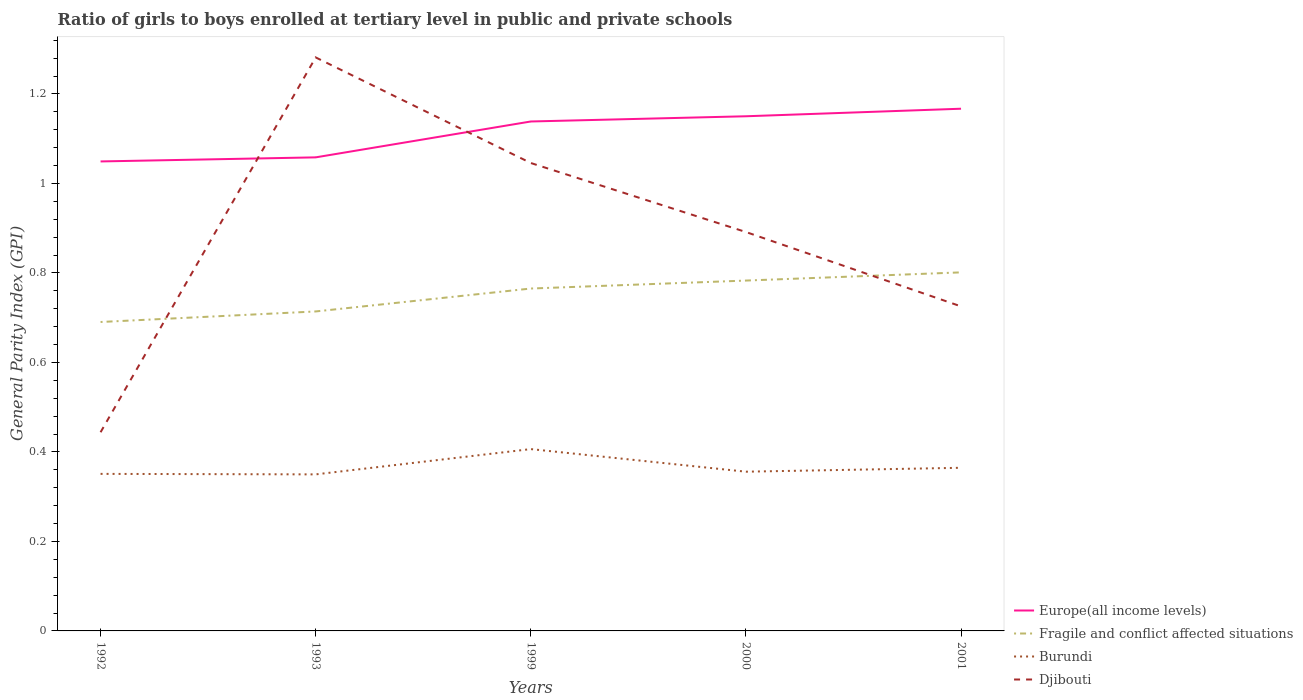How many different coloured lines are there?
Offer a very short reply. 4. Across all years, what is the maximum general parity index in Europe(all income levels)?
Provide a succinct answer. 1.05. In which year was the general parity index in Burundi maximum?
Offer a terse response. 1993. What is the total general parity index in Burundi in the graph?
Your response must be concise. 0.05. What is the difference between the highest and the second highest general parity index in Fragile and conflict affected situations?
Give a very brief answer. 0.11. Is the general parity index in Djibouti strictly greater than the general parity index in Fragile and conflict affected situations over the years?
Give a very brief answer. No. How many years are there in the graph?
Provide a short and direct response. 5. Does the graph contain any zero values?
Your response must be concise. No. Does the graph contain grids?
Offer a terse response. No. How many legend labels are there?
Give a very brief answer. 4. How are the legend labels stacked?
Give a very brief answer. Vertical. What is the title of the graph?
Ensure brevity in your answer.  Ratio of girls to boys enrolled at tertiary level in public and private schools. Does "Chad" appear as one of the legend labels in the graph?
Offer a very short reply. No. What is the label or title of the X-axis?
Ensure brevity in your answer.  Years. What is the label or title of the Y-axis?
Make the answer very short. General Parity Index (GPI). What is the General Parity Index (GPI) of Europe(all income levels) in 1992?
Offer a terse response. 1.05. What is the General Parity Index (GPI) in Fragile and conflict affected situations in 1992?
Keep it short and to the point. 0.69. What is the General Parity Index (GPI) in Burundi in 1992?
Offer a terse response. 0.35. What is the General Parity Index (GPI) in Djibouti in 1992?
Provide a short and direct response. 0.44. What is the General Parity Index (GPI) of Europe(all income levels) in 1993?
Keep it short and to the point. 1.06. What is the General Parity Index (GPI) in Fragile and conflict affected situations in 1993?
Your answer should be compact. 0.71. What is the General Parity Index (GPI) of Burundi in 1993?
Make the answer very short. 0.35. What is the General Parity Index (GPI) of Djibouti in 1993?
Offer a terse response. 1.28. What is the General Parity Index (GPI) in Europe(all income levels) in 1999?
Make the answer very short. 1.14. What is the General Parity Index (GPI) of Fragile and conflict affected situations in 1999?
Provide a succinct answer. 0.77. What is the General Parity Index (GPI) in Burundi in 1999?
Ensure brevity in your answer.  0.41. What is the General Parity Index (GPI) of Djibouti in 1999?
Offer a terse response. 1.05. What is the General Parity Index (GPI) of Europe(all income levels) in 2000?
Ensure brevity in your answer.  1.15. What is the General Parity Index (GPI) in Fragile and conflict affected situations in 2000?
Give a very brief answer. 0.78. What is the General Parity Index (GPI) in Burundi in 2000?
Provide a succinct answer. 0.36. What is the General Parity Index (GPI) in Djibouti in 2000?
Give a very brief answer. 0.89. What is the General Parity Index (GPI) in Europe(all income levels) in 2001?
Give a very brief answer. 1.17. What is the General Parity Index (GPI) of Fragile and conflict affected situations in 2001?
Your answer should be very brief. 0.8. What is the General Parity Index (GPI) of Burundi in 2001?
Your answer should be compact. 0.36. What is the General Parity Index (GPI) of Djibouti in 2001?
Provide a short and direct response. 0.73. Across all years, what is the maximum General Parity Index (GPI) in Europe(all income levels)?
Ensure brevity in your answer.  1.17. Across all years, what is the maximum General Parity Index (GPI) of Fragile and conflict affected situations?
Your answer should be very brief. 0.8. Across all years, what is the maximum General Parity Index (GPI) in Burundi?
Your answer should be compact. 0.41. Across all years, what is the maximum General Parity Index (GPI) of Djibouti?
Offer a very short reply. 1.28. Across all years, what is the minimum General Parity Index (GPI) of Europe(all income levels)?
Provide a short and direct response. 1.05. Across all years, what is the minimum General Parity Index (GPI) in Fragile and conflict affected situations?
Your response must be concise. 0.69. Across all years, what is the minimum General Parity Index (GPI) of Burundi?
Your answer should be very brief. 0.35. Across all years, what is the minimum General Parity Index (GPI) of Djibouti?
Make the answer very short. 0.44. What is the total General Parity Index (GPI) in Europe(all income levels) in the graph?
Your answer should be very brief. 5.56. What is the total General Parity Index (GPI) in Fragile and conflict affected situations in the graph?
Provide a succinct answer. 3.75. What is the total General Parity Index (GPI) of Burundi in the graph?
Ensure brevity in your answer.  1.83. What is the total General Parity Index (GPI) of Djibouti in the graph?
Your answer should be very brief. 4.39. What is the difference between the General Parity Index (GPI) of Europe(all income levels) in 1992 and that in 1993?
Make the answer very short. -0.01. What is the difference between the General Parity Index (GPI) of Fragile and conflict affected situations in 1992 and that in 1993?
Give a very brief answer. -0.02. What is the difference between the General Parity Index (GPI) in Burundi in 1992 and that in 1993?
Your answer should be compact. 0. What is the difference between the General Parity Index (GPI) in Djibouti in 1992 and that in 1993?
Ensure brevity in your answer.  -0.84. What is the difference between the General Parity Index (GPI) in Europe(all income levels) in 1992 and that in 1999?
Make the answer very short. -0.09. What is the difference between the General Parity Index (GPI) in Fragile and conflict affected situations in 1992 and that in 1999?
Your answer should be compact. -0.07. What is the difference between the General Parity Index (GPI) in Burundi in 1992 and that in 1999?
Give a very brief answer. -0.06. What is the difference between the General Parity Index (GPI) in Djibouti in 1992 and that in 1999?
Provide a succinct answer. -0.6. What is the difference between the General Parity Index (GPI) of Europe(all income levels) in 1992 and that in 2000?
Make the answer very short. -0.1. What is the difference between the General Parity Index (GPI) in Fragile and conflict affected situations in 1992 and that in 2000?
Offer a very short reply. -0.09. What is the difference between the General Parity Index (GPI) of Burundi in 1992 and that in 2000?
Your response must be concise. -0. What is the difference between the General Parity Index (GPI) of Djibouti in 1992 and that in 2000?
Give a very brief answer. -0.45. What is the difference between the General Parity Index (GPI) of Europe(all income levels) in 1992 and that in 2001?
Keep it short and to the point. -0.12. What is the difference between the General Parity Index (GPI) in Fragile and conflict affected situations in 1992 and that in 2001?
Your answer should be compact. -0.11. What is the difference between the General Parity Index (GPI) in Burundi in 1992 and that in 2001?
Offer a very short reply. -0.01. What is the difference between the General Parity Index (GPI) in Djibouti in 1992 and that in 2001?
Your response must be concise. -0.28. What is the difference between the General Parity Index (GPI) in Europe(all income levels) in 1993 and that in 1999?
Offer a terse response. -0.08. What is the difference between the General Parity Index (GPI) of Fragile and conflict affected situations in 1993 and that in 1999?
Your answer should be very brief. -0.05. What is the difference between the General Parity Index (GPI) of Burundi in 1993 and that in 1999?
Offer a very short reply. -0.06. What is the difference between the General Parity Index (GPI) in Djibouti in 1993 and that in 1999?
Your response must be concise. 0.24. What is the difference between the General Parity Index (GPI) of Europe(all income levels) in 1993 and that in 2000?
Give a very brief answer. -0.09. What is the difference between the General Parity Index (GPI) of Fragile and conflict affected situations in 1993 and that in 2000?
Your answer should be compact. -0.07. What is the difference between the General Parity Index (GPI) of Burundi in 1993 and that in 2000?
Make the answer very short. -0.01. What is the difference between the General Parity Index (GPI) of Djibouti in 1993 and that in 2000?
Give a very brief answer. 0.39. What is the difference between the General Parity Index (GPI) of Europe(all income levels) in 1993 and that in 2001?
Your answer should be compact. -0.11. What is the difference between the General Parity Index (GPI) in Fragile and conflict affected situations in 1993 and that in 2001?
Your answer should be compact. -0.09. What is the difference between the General Parity Index (GPI) in Burundi in 1993 and that in 2001?
Offer a terse response. -0.01. What is the difference between the General Parity Index (GPI) of Djibouti in 1993 and that in 2001?
Ensure brevity in your answer.  0.56. What is the difference between the General Parity Index (GPI) in Europe(all income levels) in 1999 and that in 2000?
Provide a succinct answer. -0.01. What is the difference between the General Parity Index (GPI) in Fragile and conflict affected situations in 1999 and that in 2000?
Your response must be concise. -0.02. What is the difference between the General Parity Index (GPI) of Burundi in 1999 and that in 2000?
Provide a short and direct response. 0.05. What is the difference between the General Parity Index (GPI) of Djibouti in 1999 and that in 2000?
Provide a succinct answer. 0.15. What is the difference between the General Parity Index (GPI) of Europe(all income levels) in 1999 and that in 2001?
Make the answer very short. -0.03. What is the difference between the General Parity Index (GPI) in Fragile and conflict affected situations in 1999 and that in 2001?
Ensure brevity in your answer.  -0.04. What is the difference between the General Parity Index (GPI) in Burundi in 1999 and that in 2001?
Offer a very short reply. 0.04. What is the difference between the General Parity Index (GPI) of Djibouti in 1999 and that in 2001?
Ensure brevity in your answer.  0.32. What is the difference between the General Parity Index (GPI) of Europe(all income levels) in 2000 and that in 2001?
Your answer should be compact. -0.02. What is the difference between the General Parity Index (GPI) of Fragile and conflict affected situations in 2000 and that in 2001?
Give a very brief answer. -0.02. What is the difference between the General Parity Index (GPI) of Burundi in 2000 and that in 2001?
Offer a terse response. -0.01. What is the difference between the General Parity Index (GPI) in Djibouti in 2000 and that in 2001?
Your answer should be compact. 0.17. What is the difference between the General Parity Index (GPI) in Europe(all income levels) in 1992 and the General Parity Index (GPI) in Fragile and conflict affected situations in 1993?
Give a very brief answer. 0.34. What is the difference between the General Parity Index (GPI) in Europe(all income levels) in 1992 and the General Parity Index (GPI) in Burundi in 1993?
Your answer should be compact. 0.7. What is the difference between the General Parity Index (GPI) in Europe(all income levels) in 1992 and the General Parity Index (GPI) in Djibouti in 1993?
Offer a terse response. -0.23. What is the difference between the General Parity Index (GPI) of Fragile and conflict affected situations in 1992 and the General Parity Index (GPI) of Burundi in 1993?
Keep it short and to the point. 0.34. What is the difference between the General Parity Index (GPI) in Fragile and conflict affected situations in 1992 and the General Parity Index (GPI) in Djibouti in 1993?
Make the answer very short. -0.59. What is the difference between the General Parity Index (GPI) of Burundi in 1992 and the General Parity Index (GPI) of Djibouti in 1993?
Your response must be concise. -0.93. What is the difference between the General Parity Index (GPI) of Europe(all income levels) in 1992 and the General Parity Index (GPI) of Fragile and conflict affected situations in 1999?
Your answer should be compact. 0.28. What is the difference between the General Parity Index (GPI) of Europe(all income levels) in 1992 and the General Parity Index (GPI) of Burundi in 1999?
Give a very brief answer. 0.64. What is the difference between the General Parity Index (GPI) of Europe(all income levels) in 1992 and the General Parity Index (GPI) of Djibouti in 1999?
Keep it short and to the point. 0. What is the difference between the General Parity Index (GPI) in Fragile and conflict affected situations in 1992 and the General Parity Index (GPI) in Burundi in 1999?
Give a very brief answer. 0.28. What is the difference between the General Parity Index (GPI) in Fragile and conflict affected situations in 1992 and the General Parity Index (GPI) in Djibouti in 1999?
Offer a terse response. -0.36. What is the difference between the General Parity Index (GPI) in Burundi in 1992 and the General Parity Index (GPI) in Djibouti in 1999?
Provide a succinct answer. -0.69. What is the difference between the General Parity Index (GPI) of Europe(all income levels) in 1992 and the General Parity Index (GPI) of Fragile and conflict affected situations in 2000?
Your answer should be compact. 0.27. What is the difference between the General Parity Index (GPI) in Europe(all income levels) in 1992 and the General Parity Index (GPI) in Burundi in 2000?
Offer a very short reply. 0.69. What is the difference between the General Parity Index (GPI) of Europe(all income levels) in 1992 and the General Parity Index (GPI) of Djibouti in 2000?
Offer a very short reply. 0.16. What is the difference between the General Parity Index (GPI) in Fragile and conflict affected situations in 1992 and the General Parity Index (GPI) in Burundi in 2000?
Your response must be concise. 0.33. What is the difference between the General Parity Index (GPI) of Fragile and conflict affected situations in 1992 and the General Parity Index (GPI) of Djibouti in 2000?
Make the answer very short. -0.2. What is the difference between the General Parity Index (GPI) in Burundi in 1992 and the General Parity Index (GPI) in Djibouti in 2000?
Your response must be concise. -0.54. What is the difference between the General Parity Index (GPI) of Europe(all income levels) in 1992 and the General Parity Index (GPI) of Fragile and conflict affected situations in 2001?
Provide a short and direct response. 0.25. What is the difference between the General Parity Index (GPI) of Europe(all income levels) in 1992 and the General Parity Index (GPI) of Burundi in 2001?
Your answer should be very brief. 0.68. What is the difference between the General Parity Index (GPI) of Europe(all income levels) in 1992 and the General Parity Index (GPI) of Djibouti in 2001?
Keep it short and to the point. 0.32. What is the difference between the General Parity Index (GPI) of Fragile and conflict affected situations in 1992 and the General Parity Index (GPI) of Burundi in 2001?
Offer a very short reply. 0.33. What is the difference between the General Parity Index (GPI) in Fragile and conflict affected situations in 1992 and the General Parity Index (GPI) in Djibouti in 2001?
Your answer should be compact. -0.03. What is the difference between the General Parity Index (GPI) in Burundi in 1992 and the General Parity Index (GPI) in Djibouti in 2001?
Give a very brief answer. -0.37. What is the difference between the General Parity Index (GPI) in Europe(all income levels) in 1993 and the General Parity Index (GPI) in Fragile and conflict affected situations in 1999?
Keep it short and to the point. 0.29. What is the difference between the General Parity Index (GPI) in Europe(all income levels) in 1993 and the General Parity Index (GPI) in Burundi in 1999?
Your answer should be compact. 0.65. What is the difference between the General Parity Index (GPI) of Europe(all income levels) in 1993 and the General Parity Index (GPI) of Djibouti in 1999?
Your answer should be compact. 0.01. What is the difference between the General Parity Index (GPI) of Fragile and conflict affected situations in 1993 and the General Parity Index (GPI) of Burundi in 1999?
Make the answer very short. 0.31. What is the difference between the General Parity Index (GPI) of Fragile and conflict affected situations in 1993 and the General Parity Index (GPI) of Djibouti in 1999?
Keep it short and to the point. -0.33. What is the difference between the General Parity Index (GPI) in Burundi in 1993 and the General Parity Index (GPI) in Djibouti in 1999?
Offer a terse response. -0.7. What is the difference between the General Parity Index (GPI) in Europe(all income levels) in 1993 and the General Parity Index (GPI) in Fragile and conflict affected situations in 2000?
Ensure brevity in your answer.  0.28. What is the difference between the General Parity Index (GPI) of Europe(all income levels) in 1993 and the General Parity Index (GPI) of Burundi in 2000?
Provide a short and direct response. 0.7. What is the difference between the General Parity Index (GPI) of Europe(all income levels) in 1993 and the General Parity Index (GPI) of Djibouti in 2000?
Ensure brevity in your answer.  0.17. What is the difference between the General Parity Index (GPI) of Fragile and conflict affected situations in 1993 and the General Parity Index (GPI) of Burundi in 2000?
Make the answer very short. 0.36. What is the difference between the General Parity Index (GPI) of Fragile and conflict affected situations in 1993 and the General Parity Index (GPI) of Djibouti in 2000?
Your answer should be very brief. -0.18. What is the difference between the General Parity Index (GPI) of Burundi in 1993 and the General Parity Index (GPI) of Djibouti in 2000?
Provide a succinct answer. -0.54. What is the difference between the General Parity Index (GPI) in Europe(all income levels) in 1993 and the General Parity Index (GPI) in Fragile and conflict affected situations in 2001?
Offer a terse response. 0.26. What is the difference between the General Parity Index (GPI) in Europe(all income levels) in 1993 and the General Parity Index (GPI) in Burundi in 2001?
Offer a terse response. 0.69. What is the difference between the General Parity Index (GPI) in Europe(all income levels) in 1993 and the General Parity Index (GPI) in Djibouti in 2001?
Offer a very short reply. 0.33. What is the difference between the General Parity Index (GPI) of Fragile and conflict affected situations in 1993 and the General Parity Index (GPI) of Burundi in 2001?
Offer a terse response. 0.35. What is the difference between the General Parity Index (GPI) of Fragile and conflict affected situations in 1993 and the General Parity Index (GPI) of Djibouti in 2001?
Provide a short and direct response. -0.01. What is the difference between the General Parity Index (GPI) in Burundi in 1993 and the General Parity Index (GPI) in Djibouti in 2001?
Your response must be concise. -0.38. What is the difference between the General Parity Index (GPI) of Europe(all income levels) in 1999 and the General Parity Index (GPI) of Fragile and conflict affected situations in 2000?
Keep it short and to the point. 0.36. What is the difference between the General Parity Index (GPI) of Europe(all income levels) in 1999 and the General Parity Index (GPI) of Burundi in 2000?
Keep it short and to the point. 0.78. What is the difference between the General Parity Index (GPI) in Europe(all income levels) in 1999 and the General Parity Index (GPI) in Djibouti in 2000?
Provide a short and direct response. 0.25. What is the difference between the General Parity Index (GPI) in Fragile and conflict affected situations in 1999 and the General Parity Index (GPI) in Burundi in 2000?
Provide a succinct answer. 0.41. What is the difference between the General Parity Index (GPI) in Fragile and conflict affected situations in 1999 and the General Parity Index (GPI) in Djibouti in 2000?
Give a very brief answer. -0.13. What is the difference between the General Parity Index (GPI) of Burundi in 1999 and the General Parity Index (GPI) of Djibouti in 2000?
Provide a succinct answer. -0.49. What is the difference between the General Parity Index (GPI) in Europe(all income levels) in 1999 and the General Parity Index (GPI) in Fragile and conflict affected situations in 2001?
Provide a short and direct response. 0.34. What is the difference between the General Parity Index (GPI) in Europe(all income levels) in 1999 and the General Parity Index (GPI) in Burundi in 2001?
Ensure brevity in your answer.  0.77. What is the difference between the General Parity Index (GPI) of Europe(all income levels) in 1999 and the General Parity Index (GPI) of Djibouti in 2001?
Make the answer very short. 0.41. What is the difference between the General Parity Index (GPI) of Fragile and conflict affected situations in 1999 and the General Parity Index (GPI) of Burundi in 2001?
Offer a very short reply. 0.4. What is the difference between the General Parity Index (GPI) in Fragile and conflict affected situations in 1999 and the General Parity Index (GPI) in Djibouti in 2001?
Keep it short and to the point. 0.04. What is the difference between the General Parity Index (GPI) of Burundi in 1999 and the General Parity Index (GPI) of Djibouti in 2001?
Make the answer very short. -0.32. What is the difference between the General Parity Index (GPI) of Europe(all income levels) in 2000 and the General Parity Index (GPI) of Fragile and conflict affected situations in 2001?
Offer a terse response. 0.35. What is the difference between the General Parity Index (GPI) of Europe(all income levels) in 2000 and the General Parity Index (GPI) of Burundi in 2001?
Your answer should be compact. 0.79. What is the difference between the General Parity Index (GPI) of Europe(all income levels) in 2000 and the General Parity Index (GPI) of Djibouti in 2001?
Offer a very short reply. 0.42. What is the difference between the General Parity Index (GPI) of Fragile and conflict affected situations in 2000 and the General Parity Index (GPI) of Burundi in 2001?
Provide a short and direct response. 0.42. What is the difference between the General Parity Index (GPI) in Fragile and conflict affected situations in 2000 and the General Parity Index (GPI) in Djibouti in 2001?
Keep it short and to the point. 0.06. What is the difference between the General Parity Index (GPI) in Burundi in 2000 and the General Parity Index (GPI) in Djibouti in 2001?
Provide a succinct answer. -0.37. What is the average General Parity Index (GPI) in Europe(all income levels) per year?
Provide a short and direct response. 1.11. What is the average General Parity Index (GPI) in Fragile and conflict affected situations per year?
Your answer should be very brief. 0.75. What is the average General Parity Index (GPI) of Burundi per year?
Give a very brief answer. 0.37. What is the average General Parity Index (GPI) of Djibouti per year?
Make the answer very short. 0.88. In the year 1992, what is the difference between the General Parity Index (GPI) in Europe(all income levels) and General Parity Index (GPI) in Fragile and conflict affected situations?
Your answer should be compact. 0.36. In the year 1992, what is the difference between the General Parity Index (GPI) in Europe(all income levels) and General Parity Index (GPI) in Burundi?
Your answer should be compact. 0.7. In the year 1992, what is the difference between the General Parity Index (GPI) of Europe(all income levels) and General Parity Index (GPI) of Djibouti?
Provide a succinct answer. 0.61. In the year 1992, what is the difference between the General Parity Index (GPI) in Fragile and conflict affected situations and General Parity Index (GPI) in Burundi?
Your response must be concise. 0.34. In the year 1992, what is the difference between the General Parity Index (GPI) of Fragile and conflict affected situations and General Parity Index (GPI) of Djibouti?
Ensure brevity in your answer.  0.25. In the year 1992, what is the difference between the General Parity Index (GPI) in Burundi and General Parity Index (GPI) in Djibouti?
Offer a terse response. -0.09. In the year 1993, what is the difference between the General Parity Index (GPI) in Europe(all income levels) and General Parity Index (GPI) in Fragile and conflict affected situations?
Give a very brief answer. 0.34. In the year 1993, what is the difference between the General Parity Index (GPI) in Europe(all income levels) and General Parity Index (GPI) in Burundi?
Offer a very short reply. 0.71. In the year 1993, what is the difference between the General Parity Index (GPI) in Europe(all income levels) and General Parity Index (GPI) in Djibouti?
Provide a short and direct response. -0.22. In the year 1993, what is the difference between the General Parity Index (GPI) in Fragile and conflict affected situations and General Parity Index (GPI) in Burundi?
Provide a short and direct response. 0.36. In the year 1993, what is the difference between the General Parity Index (GPI) of Fragile and conflict affected situations and General Parity Index (GPI) of Djibouti?
Your answer should be compact. -0.57. In the year 1993, what is the difference between the General Parity Index (GPI) in Burundi and General Parity Index (GPI) in Djibouti?
Keep it short and to the point. -0.93. In the year 1999, what is the difference between the General Parity Index (GPI) of Europe(all income levels) and General Parity Index (GPI) of Fragile and conflict affected situations?
Your answer should be compact. 0.37. In the year 1999, what is the difference between the General Parity Index (GPI) in Europe(all income levels) and General Parity Index (GPI) in Burundi?
Your answer should be compact. 0.73. In the year 1999, what is the difference between the General Parity Index (GPI) of Europe(all income levels) and General Parity Index (GPI) of Djibouti?
Give a very brief answer. 0.09. In the year 1999, what is the difference between the General Parity Index (GPI) in Fragile and conflict affected situations and General Parity Index (GPI) in Burundi?
Offer a very short reply. 0.36. In the year 1999, what is the difference between the General Parity Index (GPI) in Fragile and conflict affected situations and General Parity Index (GPI) in Djibouti?
Your answer should be very brief. -0.28. In the year 1999, what is the difference between the General Parity Index (GPI) of Burundi and General Parity Index (GPI) of Djibouti?
Offer a terse response. -0.64. In the year 2000, what is the difference between the General Parity Index (GPI) of Europe(all income levels) and General Parity Index (GPI) of Fragile and conflict affected situations?
Your answer should be compact. 0.37. In the year 2000, what is the difference between the General Parity Index (GPI) in Europe(all income levels) and General Parity Index (GPI) in Burundi?
Keep it short and to the point. 0.79. In the year 2000, what is the difference between the General Parity Index (GPI) in Europe(all income levels) and General Parity Index (GPI) in Djibouti?
Offer a terse response. 0.26. In the year 2000, what is the difference between the General Parity Index (GPI) in Fragile and conflict affected situations and General Parity Index (GPI) in Burundi?
Provide a short and direct response. 0.43. In the year 2000, what is the difference between the General Parity Index (GPI) in Fragile and conflict affected situations and General Parity Index (GPI) in Djibouti?
Offer a very short reply. -0.11. In the year 2000, what is the difference between the General Parity Index (GPI) of Burundi and General Parity Index (GPI) of Djibouti?
Make the answer very short. -0.54. In the year 2001, what is the difference between the General Parity Index (GPI) in Europe(all income levels) and General Parity Index (GPI) in Fragile and conflict affected situations?
Provide a succinct answer. 0.37. In the year 2001, what is the difference between the General Parity Index (GPI) of Europe(all income levels) and General Parity Index (GPI) of Burundi?
Provide a short and direct response. 0.8. In the year 2001, what is the difference between the General Parity Index (GPI) in Europe(all income levels) and General Parity Index (GPI) in Djibouti?
Provide a succinct answer. 0.44. In the year 2001, what is the difference between the General Parity Index (GPI) in Fragile and conflict affected situations and General Parity Index (GPI) in Burundi?
Ensure brevity in your answer.  0.44. In the year 2001, what is the difference between the General Parity Index (GPI) of Fragile and conflict affected situations and General Parity Index (GPI) of Djibouti?
Make the answer very short. 0.08. In the year 2001, what is the difference between the General Parity Index (GPI) of Burundi and General Parity Index (GPI) of Djibouti?
Ensure brevity in your answer.  -0.36. What is the ratio of the General Parity Index (GPI) in Burundi in 1992 to that in 1993?
Your response must be concise. 1. What is the ratio of the General Parity Index (GPI) of Djibouti in 1992 to that in 1993?
Your response must be concise. 0.35. What is the ratio of the General Parity Index (GPI) of Europe(all income levels) in 1992 to that in 1999?
Ensure brevity in your answer.  0.92. What is the ratio of the General Parity Index (GPI) in Fragile and conflict affected situations in 1992 to that in 1999?
Ensure brevity in your answer.  0.9. What is the ratio of the General Parity Index (GPI) of Burundi in 1992 to that in 1999?
Give a very brief answer. 0.86. What is the ratio of the General Parity Index (GPI) of Djibouti in 1992 to that in 1999?
Offer a very short reply. 0.42. What is the ratio of the General Parity Index (GPI) of Europe(all income levels) in 1992 to that in 2000?
Provide a short and direct response. 0.91. What is the ratio of the General Parity Index (GPI) of Fragile and conflict affected situations in 1992 to that in 2000?
Give a very brief answer. 0.88. What is the ratio of the General Parity Index (GPI) of Burundi in 1992 to that in 2000?
Your response must be concise. 0.99. What is the ratio of the General Parity Index (GPI) in Djibouti in 1992 to that in 2000?
Provide a succinct answer. 0.5. What is the ratio of the General Parity Index (GPI) in Europe(all income levels) in 1992 to that in 2001?
Offer a very short reply. 0.9. What is the ratio of the General Parity Index (GPI) of Fragile and conflict affected situations in 1992 to that in 2001?
Your answer should be very brief. 0.86. What is the ratio of the General Parity Index (GPI) of Burundi in 1992 to that in 2001?
Make the answer very short. 0.96. What is the ratio of the General Parity Index (GPI) of Djibouti in 1992 to that in 2001?
Your response must be concise. 0.61. What is the ratio of the General Parity Index (GPI) in Europe(all income levels) in 1993 to that in 1999?
Offer a terse response. 0.93. What is the ratio of the General Parity Index (GPI) of Fragile and conflict affected situations in 1993 to that in 1999?
Make the answer very short. 0.93. What is the ratio of the General Parity Index (GPI) of Burundi in 1993 to that in 1999?
Provide a succinct answer. 0.86. What is the ratio of the General Parity Index (GPI) in Djibouti in 1993 to that in 1999?
Your answer should be compact. 1.23. What is the ratio of the General Parity Index (GPI) of Europe(all income levels) in 1993 to that in 2000?
Make the answer very short. 0.92. What is the ratio of the General Parity Index (GPI) in Fragile and conflict affected situations in 1993 to that in 2000?
Offer a very short reply. 0.91. What is the ratio of the General Parity Index (GPI) of Burundi in 1993 to that in 2000?
Offer a very short reply. 0.98. What is the ratio of the General Parity Index (GPI) of Djibouti in 1993 to that in 2000?
Your answer should be compact. 1.44. What is the ratio of the General Parity Index (GPI) in Europe(all income levels) in 1993 to that in 2001?
Give a very brief answer. 0.91. What is the ratio of the General Parity Index (GPI) of Fragile and conflict affected situations in 1993 to that in 2001?
Offer a terse response. 0.89. What is the ratio of the General Parity Index (GPI) in Burundi in 1993 to that in 2001?
Ensure brevity in your answer.  0.96. What is the ratio of the General Parity Index (GPI) in Djibouti in 1993 to that in 2001?
Give a very brief answer. 1.77. What is the ratio of the General Parity Index (GPI) of Europe(all income levels) in 1999 to that in 2000?
Your answer should be very brief. 0.99. What is the ratio of the General Parity Index (GPI) in Fragile and conflict affected situations in 1999 to that in 2000?
Make the answer very short. 0.98. What is the ratio of the General Parity Index (GPI) of Burundi in 1999 to that in 2000?
Offer a very short reply. 1.14. What is the ratio of the General Parity Index (GPI) in Djibouti in 1999 to that in 2000?
Offer a terse response. 1.17. What is the ratio of the General Parity Index (GPI) in Europe(all income levels) in 1999 to that in 2001?
Provide a succinct answer. 0.98. What is the ratio of the General Parity Index (GPI) of Fragile and conflict affected situations in 1999 to that in 2001?
Make the answer very short. 0.95. What is the ratio of the General Parity Index (GPI) of Burundi in 1999 to that in 2001?
Your answer should be compact. 1.11. What is the ratio of the General Parity Index (GPI) of Djibouti in 1999 to that in 2001?
Keep it short and to the point. 1.44. What is the ratio of the General Parity Index (GPI) of Europe(all income levels) in 2000 to that in 2001?
Your answer should be very brief. 0.99. What is the ratio of the General Parity Index (GPI) of Fragile and conflict affected situations in 2000 to that in 2001?
Provide a short and direct response. 0.98. What is the ratio of the General Parity Index (GPI) in Burundi in 2000 to that in 2001?
Provide a short and direct response. 0.98. What is the ratio of the General Parity Index (GPI) of Djibouti in 2000 to that in 2001?
Offer a very short reply. 1.23. What is the difference between the highest and the second highest General Parity Index (GPI) in Europe(all income levels)?
Ensure brevity in your answer.  0.02. What is the difference between the highest and the second highest General Parity Index (GPI) in Fragile and conflict affected situations?
Give a very brief answer. 0.02. What is the difference between the highest and the second highest General Parity Index (GPI) in Burundi?
Keep it short and to the point. 0.04. What is the difference between the highest and the second highest General Parity Index (GPI) of Djibouti?
Keep it short and to the point. 0.24. What is the difference between the highest and the lowest General Parity Index (GPI) of Europe(all income levels)?
Your response must be concise. 0.12. What is the difference between the highest and the lowest General Parity Index (GPI) of Fragile and conflict affected situations?
Your answer should be compact. 0.11. What is the difference between the highest and the lowest General Parity Index (GPI) of Burundi?
Ensure brevity in your answer.  0.06. What is the difference between the highest and the lowest General Parity Index (GPI) of Djibouti?
Keep it short and to the point. 0.84. 